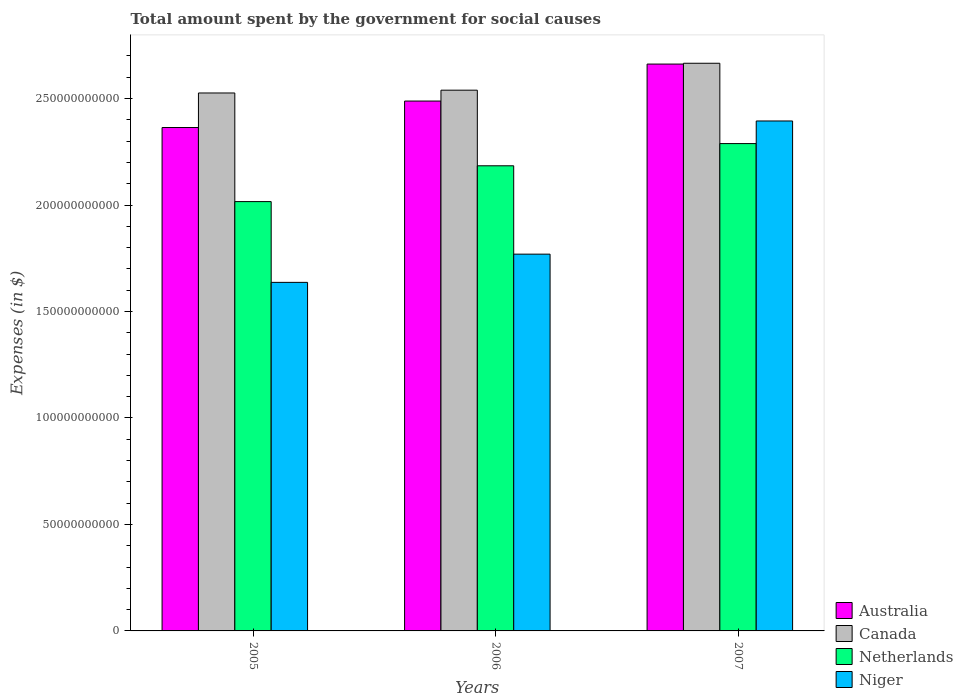Are the number of bars on each tick of the X-axis equal?
Offer a very short reply. Yes. What is the amount spent for social causes by the government in Netherlands in 2007?
Offer a terse response. 2.29e+11. Across all years, what is the maximum amount spent for social causes by the government in Niger?
Offer a very short reply. 2.39e+11. Across all years, what is the minimum amount spent for social causes by the government in Niger?
Keep it short and to the point. 1.64e+11. In which year was the amount spent for social causes by the government in Niger minimum?
Your answer should be compact. 2005. What is the total amount spent for social causes by the government in Canada in the graph?
Give a very brief answer. 7.73e+11. What is the difference between the amount spent for social causes by the government in Niger in 2005 and that in 2006?
Offer a very short reply. -1.32e+1. What is the difference between the amount spent for social causes by the government in Canada in 2005 and the amount spent for social causes by the government in Niger in 2006?
Offer a terse response. 7.57e+1. What is the average amount spent for social causes by the government in Niger per year?
Ensure brevity in your answer.  1.93e+11. In the year 2006, what is the difference between the amount spent for social causes by the government in Netherlands and amount spent for social causes by the government in Australia?
Offer a terse response. -3.04e+1. What is the ratio of the amount spent for social causes by the government in Canada in 2006 to that in 2007?
Provide a short and direct response. 0.95. What is the difference between the highest and the second highest amount spent for social causes by the government in Canada?
Offer a terse response. 1.26e+1. What is the difference between the highest and the lowest amount spent for social causes by the government in Niger?
Your answer should be very brief. 7.58e+1. Is it the case that in every year, the sum of the amount spent for social causes by the government in Australia and amount spent for social causes by the government in Netherlands is greater than the sum of amount spent for social causes by the government in Canada and amount spent for social causes by the government in Niger?
Offer a very short reply. No. What does the 4th bar from the right in 2005 represents?
Make the answer very short. Australia. Is it the case that in every year, the sum of the amount spent for social causes by the government in Netherlands and amount spent for social causes by the government in Canada is greater than the amount spent for social causes by the government in Niger?
Provide a short and direct response. Yes. How many bars are there?
Your answer should be compact. 12. Does the graph contain grids?
Provide a short and direct response. No. Where does the legend appear in the graph?
Your response must be concise. Bottom right. What is the title of the graph?
Make the answer very short. Total amount spent by the government for social causes. Does "St. Martin (French part)" appear as one of the legend labels in the graph?
Your answer should be compact. No. What is the label or title of the Y-axis?
Give a very brief answer. Expenses (in $). What is the Expenses (in $) of Australia in 2005?
Offer a very short reply. 2.36e+11. What is the Expenses (in $) of Canada in 2005?
Offer a very short reply. 2.53e+11. What is the Expenses (in $) of Netherlands in 2005?
Offer a terse response. 2.02e+11. What is the Expenses (in $) in Niger in 2005?
Give a very brief answer. 1.64e+11. What is the Expenses (in $) in Australia in 2006?
Your response must be concise. 2.49e+11. What is the Expenses (in $) of Canada in 2006?
Ensure brevity in your answer.  2.54e+11. What is the Expenses (in $) in Netherlands in 2006?
Make the answer very short. 2.18e+11. What is the Expenses (in $) of Niger in 2006?
Your answer should be very brief. 1.77e+11. What is the Expenses (in $) in Australia in 2007?
Offer a very short reply. 2.66e+11. What is the Expenses (in $) of Canada in 2007?
Make the answer very short. 2.67e+11. What is the Expenses (in $) in Netherlands in 2007?
Your answer should be compact. 2.29e+11. What is the Expenses (in $) of Niger in 2007?
Offer a terse response. 2.39e+11. Across all years, what is the maximum Expenses (in $) in Australia?
Your response must be concise. 2.66e+11. Across all years, what is the maximum Expenses (in $) in Canada?
Offer a very short reply. 2.67e+11. Across all years, what is the maximum Expenses (in $) in Netherlands?
Ensure brevity in your answer.  2.29e+11. Across all years, what is the maximum Expenses (in $) of Niger?
Keep it short and to the point. 2.39e+11. Across all years, what is the minimum Expenses (in $) in Australia?
Give a very brief answer. 2.36e+11. Across all years, what is the minimum Expenses (in $) in Canada?
Keep it short and to the point. 2.53e+11. Across all years, what is the minimum Expenses (in $) in Netherlands?
Keep it short and to the point. 2.02e+11. Across all years, what is the minimum Expenses (in $) of Niger?
Ensure brevity in your answer.  1.64e+11. What is the total Expenses (in $) of Australia in the graph?
Your answer should be compact. 7.51e+11. What is the total Expenses (in $) of Canada in the graph?
Provide a succinct answer. 7.73e+11. What is the total Expenses (in $) of Netherlands in the graph?
Provide a succinct answer. 6.49e+11. What is the total Expenses (in $) of Niger in the graph?
Your answer should be compact. 5.80e+11. What is the difference between the Expenses (in $) of Australia in 2005 and that in 2006?
Offer a very short reply. -1.24e+1. What is the difference between the Expenses (in $) of Canada in 2005 and that in 2006?
Provide a succinct answer. -1.32e+09. What is the difference between the Expenses (in $) in Netherlands in 2005 and that in 2006?
Ensure brevity in your answer.  -1.68e+1. What is the difference between the Expenses (in $) in Niger in 2005 and that in 2006?
Your answer should be compact. -1.32e+1. What is the difference between the Expenses (in $) of Australia in 2005 and that in 2007?
Your response must be concise. -2.98e+1. What is the difference between the Expenses (in $) in Canada in 2005 and that in 2007?
Offer a terse response. -1.40e+1. What is the difference between the Expenses (in $) of Netherlands in 2005 and that in 2007?
Offer a very short reply. -2.72e+1. What is the difference between the Expenses (in $) in Niger in 2005 and that in 2007?
Make the answer very short. -7.58e+1. What is the difference between the Expenses (in $) in Australia in 2006 and that in 2007?
Provide a short and direct response. -1.74e+1. What is the difference between the Expenses (in $) of Canada in 2006 and that in 2007?
Make the answer very short. -1.26e+1. What is the difference between the Expenses (in $) in Netherlands in 2006 and that in 2007?
Offer a very short reply. -1.04e+1. What is the difference between the Expenses (in $) in Niger in 2006 and that in 2007?
Offer a terse response. -6.25e+1. What is the difference between the Expenses (in $) in Australia in 2005 and the Expenses (in $) in Canada in 2006?
Offer a very short reply. -1.75e+1. What is the difference between the Expenses (in $) of Australia in 2005 and the Expenses (in $) of Netherlands in 2006?
Provide a short and direct response. 1.80e+1. What is the difference between the Expenses (in $) of Australia in 2005 and the Expenses (in $) of Niger in 2006?
Offer a very short reply. 5.95e+1. What is the difference between the Expenses (in $) in Canada in 2005 and the Expenses (in $) in Netherlands in 2006?
Provide a short and direct response. 3.42e+1. What is the difference between the Expenses (in $) of Canada in 2005 and the Expenses (in $) of Niger in 2006?
Your response must be concise. 7.57e+1. What is the difference between the Expenses (in $) of Netherlands in 2005 and the Expenses (in $) of Niger in 2006?
Your response must be concise. 2.47e+1. What is the difference between the Expenses (in $) in Australia in 2005 and the Expenses (in $) in Canada in 2007?
Give a very brief answer. -3.02e+1. What is the difference between the Expenses (in $) in Australia in 2005 and the Expenses (in $) in Netherlands in 2007?
Keep it short and to the point. 7.54e+09. What is the difference between the Expenses (in $) of Australia in 2005 and the Expenses (in $) of Niger in 2007?
Provide a succinct answer. -3.08e+09. What is the difference between the Expenses (in $) of Canada in 2005 and the Expenses (in $) of Netherlands in 2007?
Provide a short and direct response. 2.38e+1. What is the difference between the Expenses (in $) in Canada in 2005 and the Expenses (in $) in Niger in 2007?
Offer a very short reply. 1.31e+1. What is the difference between the Expenses (in $) of Netherlands in 2005 and the Expenses (in $) of Niger in 2007?
Your response must be concise. -3.79e+1. What is the difference between the Expenses (in $) of Australia in 2006 and the Expenses (in $) of Canada in 2007?
Your response must be concise. -1.78e+1. What is the difference between the Expenses (in $) of Australia in 2006 and the Expenses (in $) of Netherlands in 2007?
Your response must be concise. 2.00e+1. What is the difference between the Expenses (in $) of Australia in 2006 and the Expenses (in $) of Niger in 2007?
Make the answer very short. 9.35e+09. What is the difference between the Expenses (in $) in Canada in 2006 and the Expenses (in $) in Netherlands in 2007?
Provide a succinct answer. 2.51e+1. What is the difference between the Expenses (in $) of Canada in 2006 and the Expenses (in $) of Niger in 2007?
Offer a terse response. 1.45e+1. What is the difference between the Expenses (in $) in Netherlands in 2006 and the Expenses (in $) in Niger in 2007?
Ensure brevity in your answer.  -2.10e+1. What is the average Expenses (in $) in Australia per year?
Your response must be concise. 2.50e+11. What is the average Expenses (in $) of Canada per year?
Offer a terse response. 2.58e+11. What is the average Expenses (in $) of Netherlands per year?
Give a very brief answer. 2.16e+11. What is the average Expenses (in $) in Niger per year?
Keep it short and to the point. 1.93e+11. In the year 2005, what is the difference between the Expenses (in $) in Australia and Expenses (in $) in Canada?
Your response must be concise. -1.62e+1. In the year 2005, what is the difference between the Expenses (in $) in Australia and Expenses (in $) in Netherlands?
Provide a short and direct response. 3.48e+1. In the year 2005, what is the difference between the Expenses (in $) in Australia and Expenses (in $) in Niger?
Your answer should be compact. 7.27e+1. In the year 2005, what is the difference between the Expenses (in $) of Canada and Expenses (in $) of Netherlands?
Give a very brief answer. 5.10e+1. In the year 2005, what is the difference between the Expenses (in $) in Canada and Expenses (in $) in Niger?
Make the answer very short. 8.89e+1. In the year 2005, what is the difference between the Expenses (in $) of Netherlands and Expenses (in $) of Niger?
Ensure brevity in your answer.  3.79e+1. In the year 2006, what is the difference between the Expenses (in $) of Australia and Expenses (in $) of Canada?
Offer a very short reply. -5.11e+09. In the year 2006, what is the difference between the Expenses (in $) of Australia and Expenses (in $) of Netherlands?
Provide a short and direct response. 3.04e+1. In the year 2006, what is the difference between the Expenses (in $) of Australia and Expenses (in $) of Niger?
Keep it short and to the point. 7.19e+1. In the year 2006, what is the difference between the Expenses (in $) of Canada and Expenses (in $) of Netherlands?
Give a very brief answer. 3.55e+1. In the year 2006, what is the difference between the Expenses (in $) of Canada and Expenses (in $) of Niger?
Offer a very short reply. 7.70e+1. In the year 2006, what is the difference between the Expenses (in $) in Netherlands and Expenses (in $) in Niger?
Give a very brief answer. 4.15e+1. In the year 2007, what is the difference between the Expenses (in $) in Australia and Expenses (in $) in Canada?
Make the answer very short. -3.83e+08. In the year 2007, what is the difference between the Expenses (in $) in Australia and Expenses (in $) in Netherlands?
Provide a short and direct response. 3.73e+1. In the year 2007, what is the difference between the Expenses (in $) of Australia and Expenses (in $) of Niger?
Your answer should be compact. 2.67e+1. In the year 2007, what is the difference between the Expenses (in $) of Canada and Expenses (in $) of Netherlands?
Your answer should be very brief. 3.77e+1. In the year 2007, what is the difference between the Expenses (in $) in Canada and Expenses (in $) in Niger?
Your answer should be compact. 2.71e+1. In the year 2007, what is the difference between the Expenses (in $) in Netherlands and Expenses (in $) in Niger?
Give a very brief answer. -1.06e+1. What is the ratio of the Expenses (in $) in Australia in 2005 to that in 2006?
Keep it short and to the point. 0.95. What is the ratio of the Expenses (in $) of Canada in 2005 to that in 2006?
Offer a terse response. 0.99. What is the ratio of the Expenses (in $) in Netherlands in 2005 to that in 2006?
Offer a terse response. 0.92. What is the ratio of the Expenses (in $) in Niger in 2005 to that in 2006?
Keep it short and to the point. 0.93. What is the ratio of the Expenses (in $) in Australia in 2005 to that in 2007?
Offer a terse response. 0.89. What is the ratio of the Expenses (in $) in Canada in 2005 to that in 2007?
Ensure brevity in your answer.  0.95. What is the ratio of the Expenses (in $) in Netherlands in 2005 to that in 2007?
Offer a very short reply. 0.88. What is the ratio of the Expenses (in $) in Niger in 2005 to that in 2007?
Offer a very short reply. 0.68. What is the ratio of the Expenses (in $) of Australia in 2006 to that in 2007?
Ensure brevity in your answer.  0.93. What is the ratio of the Expenses (in $) in Canada in 2006 to that in 2007?
Ensure brevity in your answer.  0.95. What is the ratio of the Expenses (in $) in Netherlands in 2006 to that in 2007?
Offer a very short reply. 0.95. What is the ratio of the Expenses (in $) in Niger in 2006 to that in 2007?
Offer a terse response. 0.74. What is the difference between the highest and the second highest Expenses (in $) of Australia?
Offer a terse response. 1.74e+1. What is the difference between the highest and the second highest Expenses (in $) in Canada?
Offer a very short reply. 1.26e+1. What is the difference between the highest and the second highest Expenses (in $) in Netherlands?
Keep it short and to the point. 1.04e+1. What is the difference between the highest and the second highest Expenses (in $) in Niger?
Give a very brief answer. 6.25e+1. What is the difference between the highest and the lowest Expenses (in $) in Australia?
Keep it short and to the point. 2.98e+1. What is the difference between the highest and the lowest Expenses (in $) in Canada?
Provide a short and direct response. 1.40e+1. What is the difference between the highest and the lowest Expenses (in $) of Netherlands?
Provide a succinct answer. 2.72e+1. What is the difference between the highest and the lowest Expenses (in $) in Niger?
Give a very brief answer. 7.58e+1. 